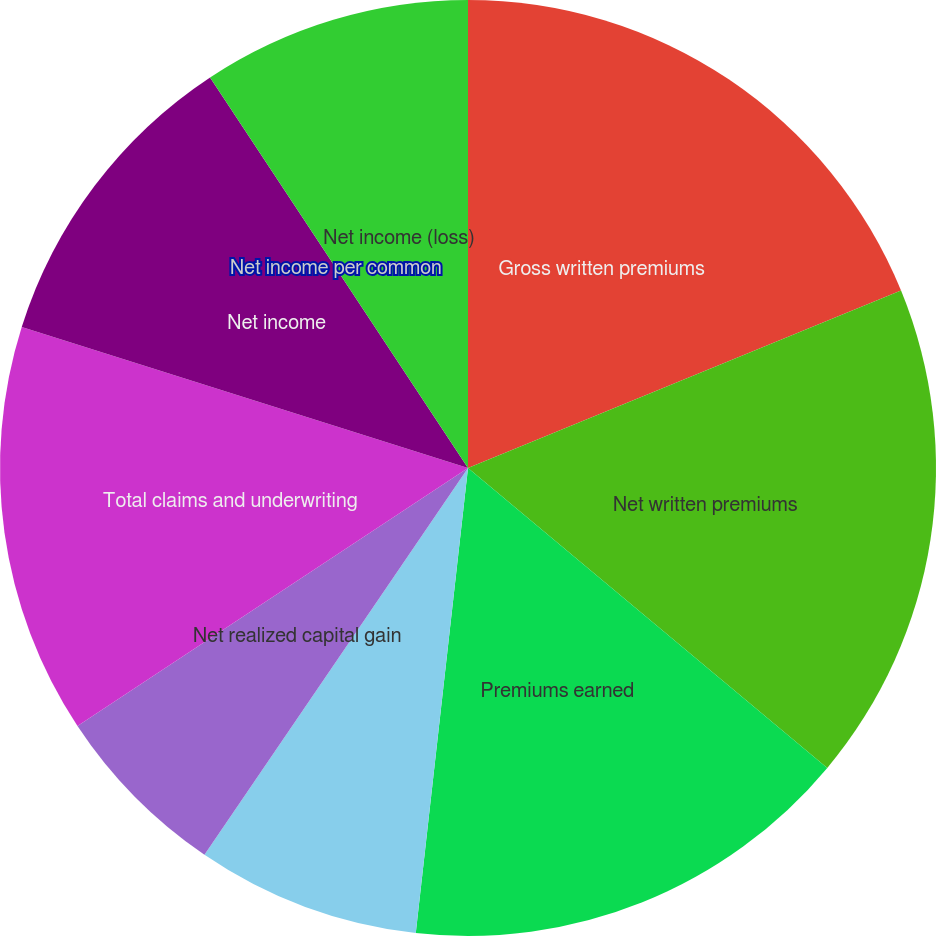Convert chart. <chart><loc_0><loc_0><loc_500><loc_500><pie_chart><fcel>Gross written premiums<fcel>Net written premiums<fcel>Premiums earned<fcel>Net investment income<fcel>Net realized capital gain<fcel>Total claims and underwriting<fcel>Net income<fcel>Net income per common<fcel>Net income (loss)<nl><fcel>18.81%<fcel>17.26%<fcel>15.71%<fcel>7.74%<fcel>6.19%<fcel>14.16%<fcel>10.84%<fcel>0.0%<fcel>9.29%<nl></chart> 